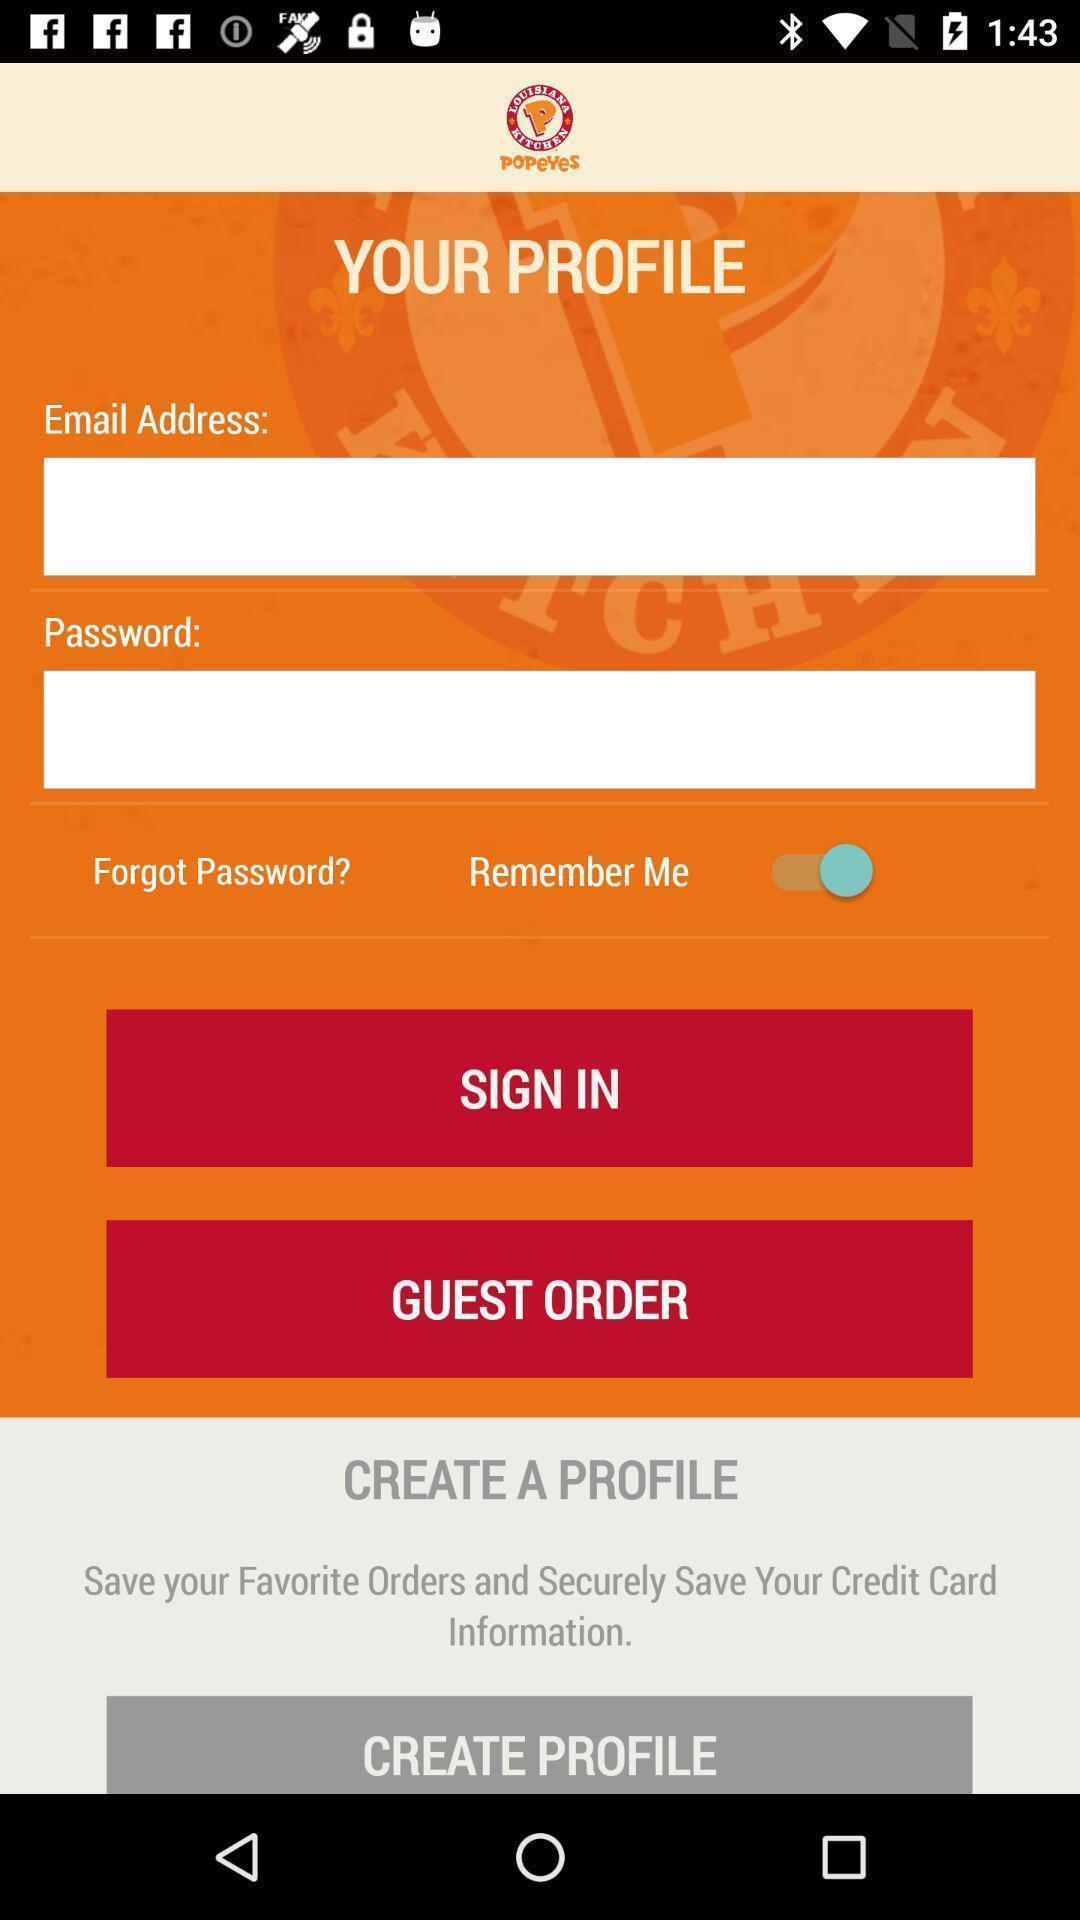Summarize the main components in this picture. Sign in page. 